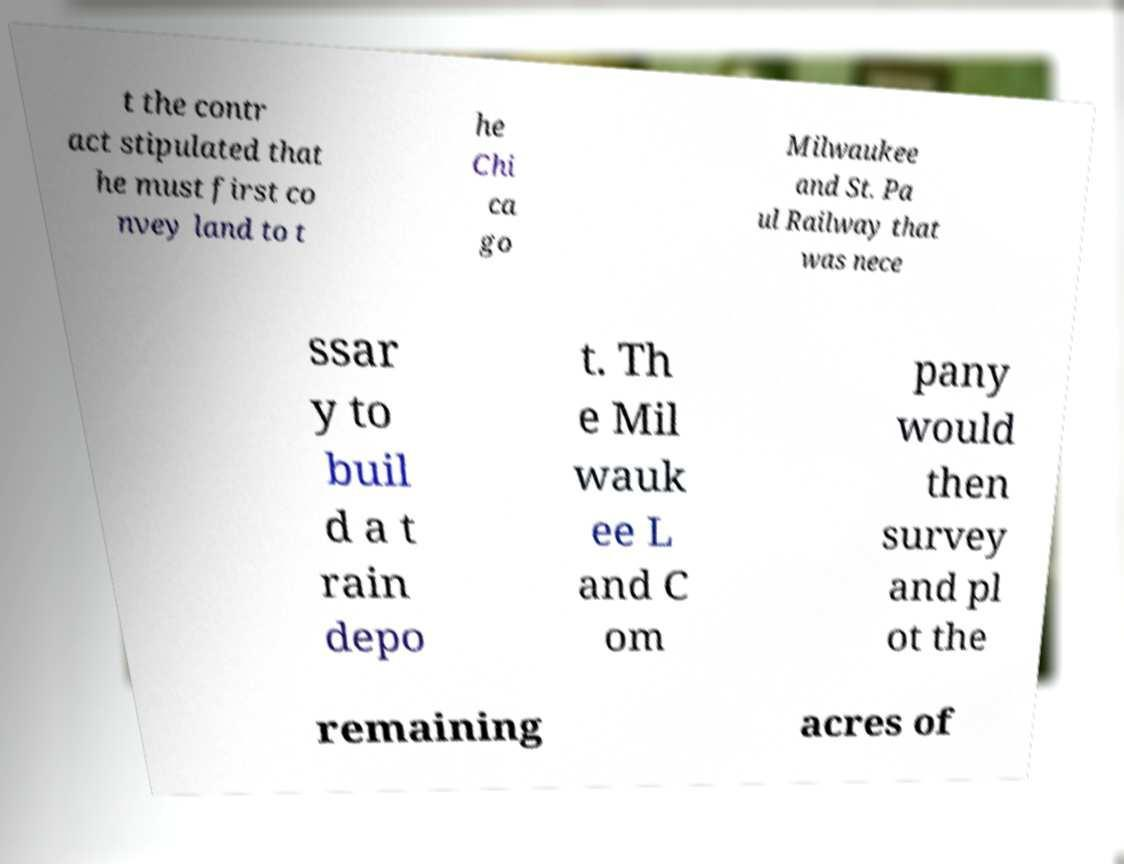Please identify and transcribe the text found in this image. t the contr act stipulated that he must first co nvey land to t he Chi ca go Milwaukee and St. Pa ul Railway that was nece ssar y to buil d a t rain depo t. Th e Mil wauk ee L and C om pany would then survey and pl ot the remaining acres of 